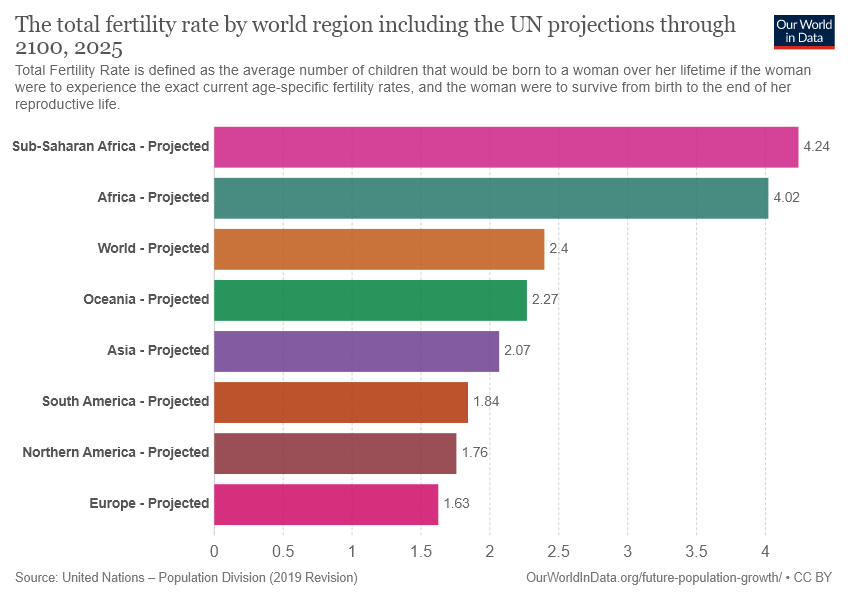Identify some key points in this picture. The number of color bars used in the graph is 8. The sum of the smallest two bars is less than the value of the largest bar. 